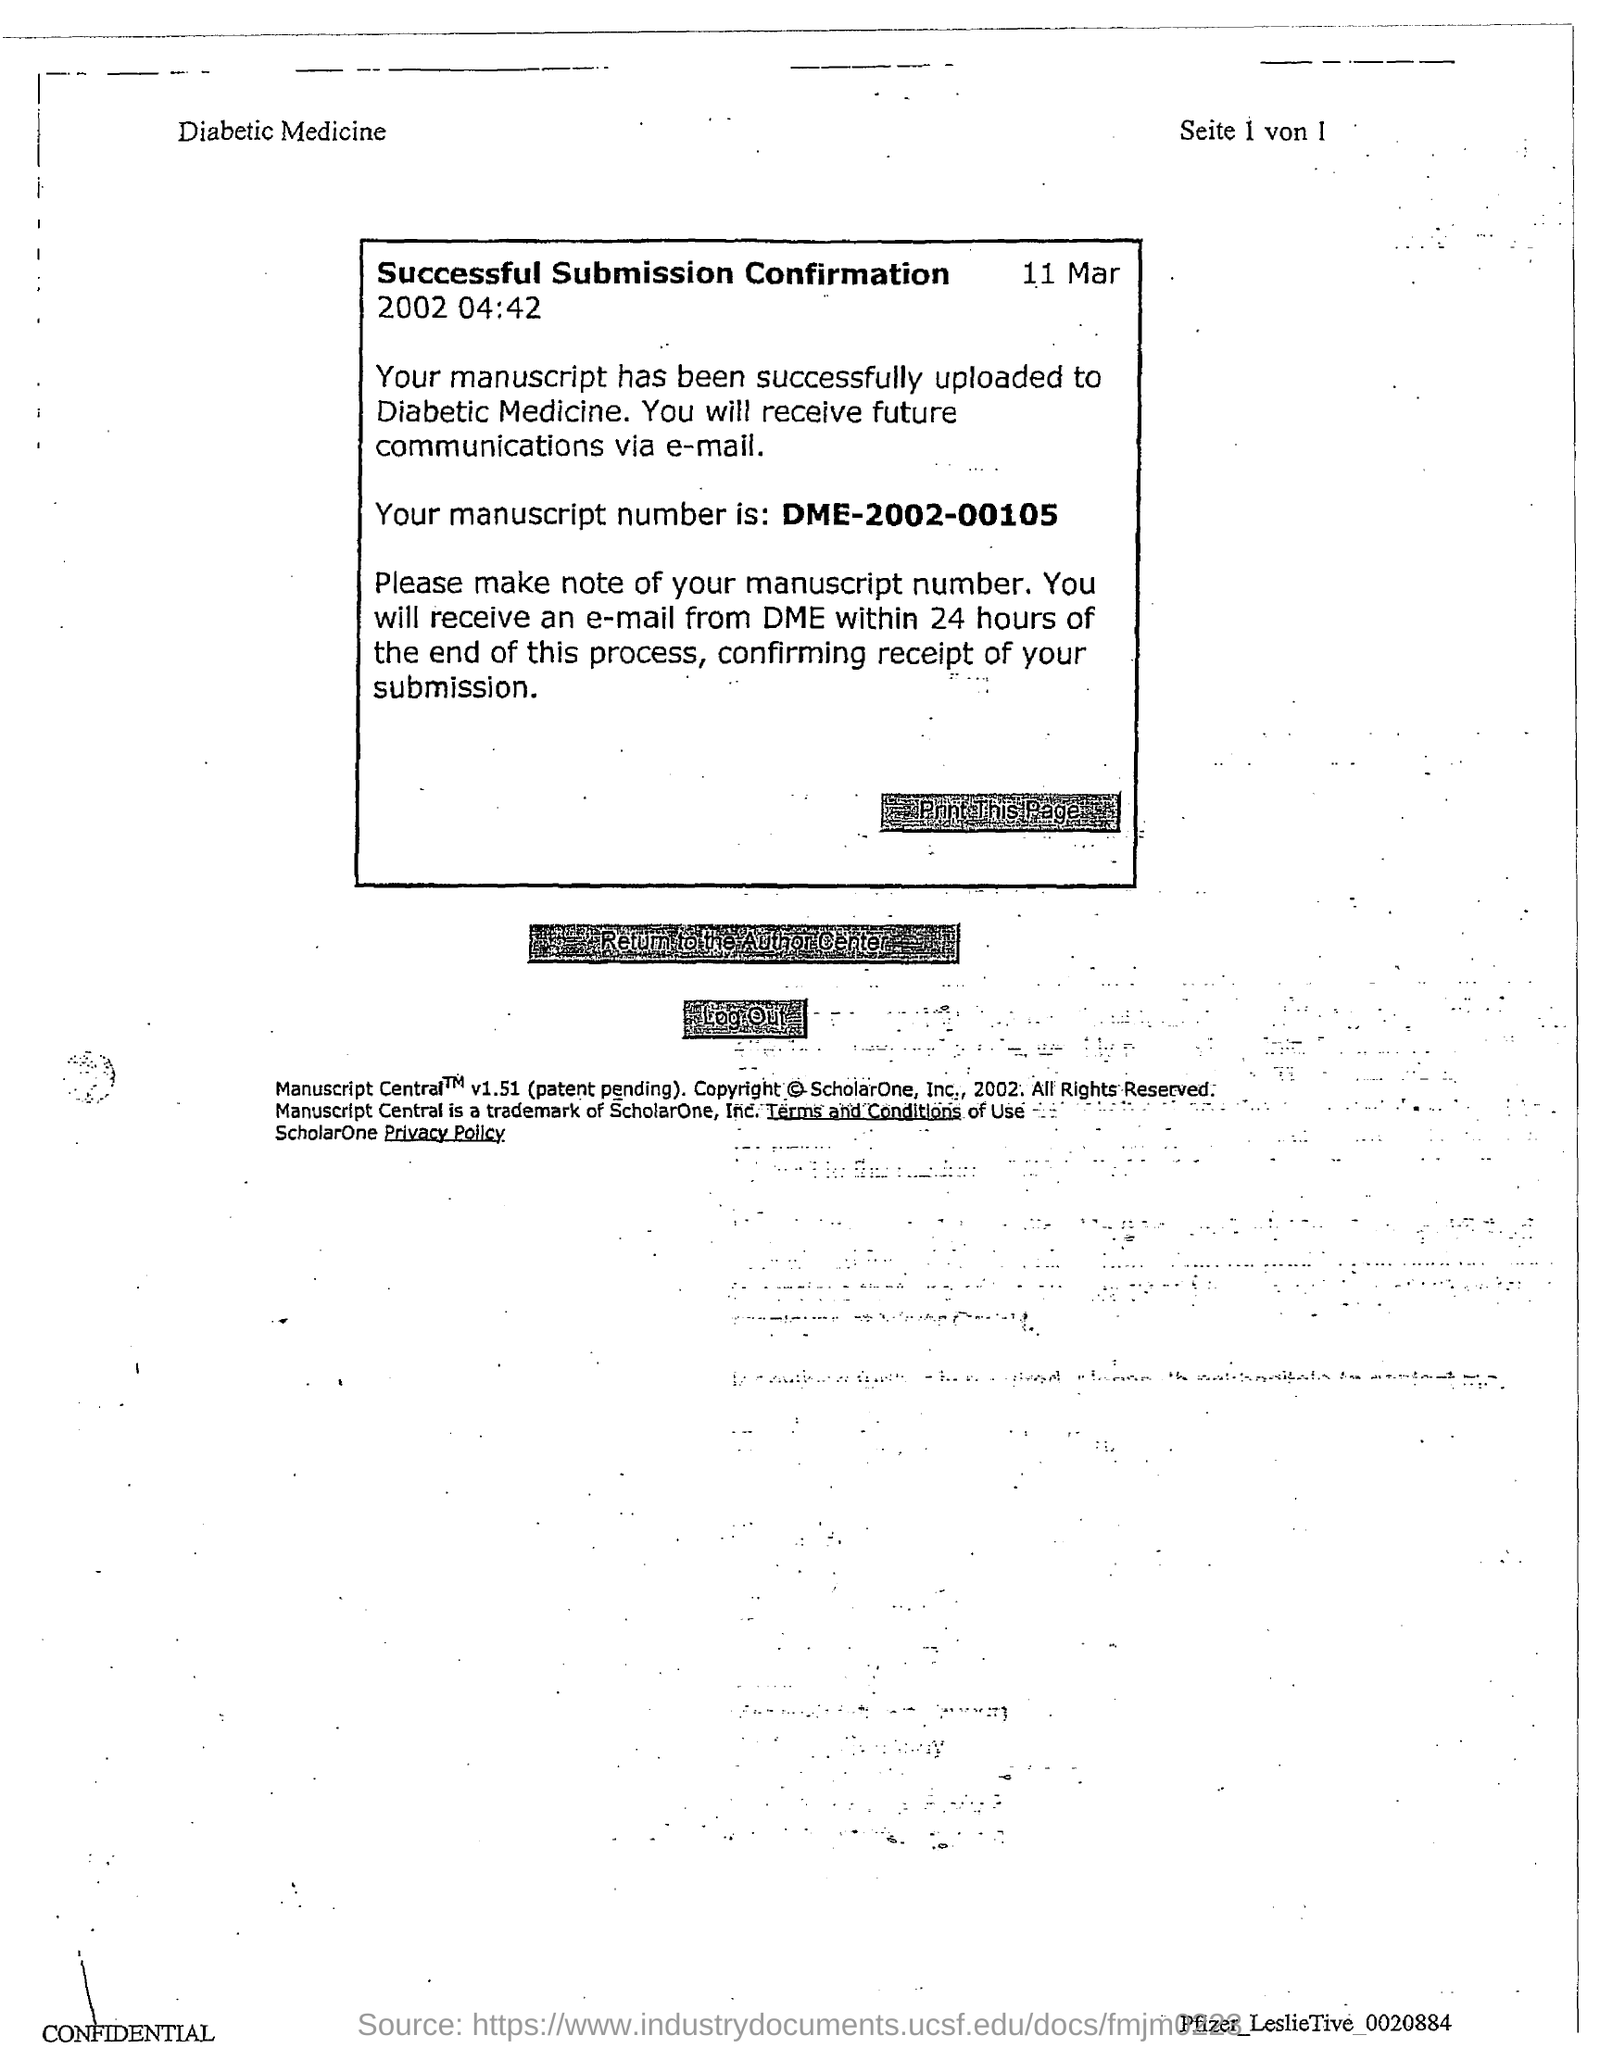Highlight a few significant elements in this photo. The manuscript number mentioned in the document is DME-2002-00105. The date and time mentioned in this document is March 11, 2002 at 04:42. 